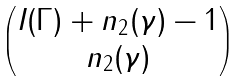<formula> <loc_0><loc_0><loc_500><loc_500>\begin{pmatrix} I ( \Gamma ) + n _ { 2 } ( \gamma ) - 1 \\ n _ { 2 } ( \gamma ) \end{pmatrix}</formula> 